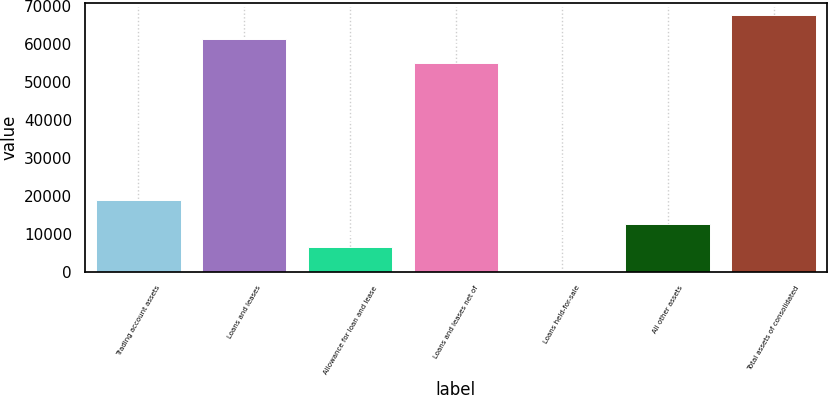<chart> <loc_0><loc_0><loc_500><loc_500><bar_chart><fcel>Trading account assets<fcel>Loans and leases<fcel>Allowance for loan and lease<fcel>Loans and leases net of<fcel>Loans held-for-sale<fcel>All other assets<fcel>Total assets of consolidated<nl><fcel>18889.4<fcel>61202.8<fcel>6421.8<fcel>54969<fcel>188<fcel>12655.6<fcel>67436.6<nl></chart> 